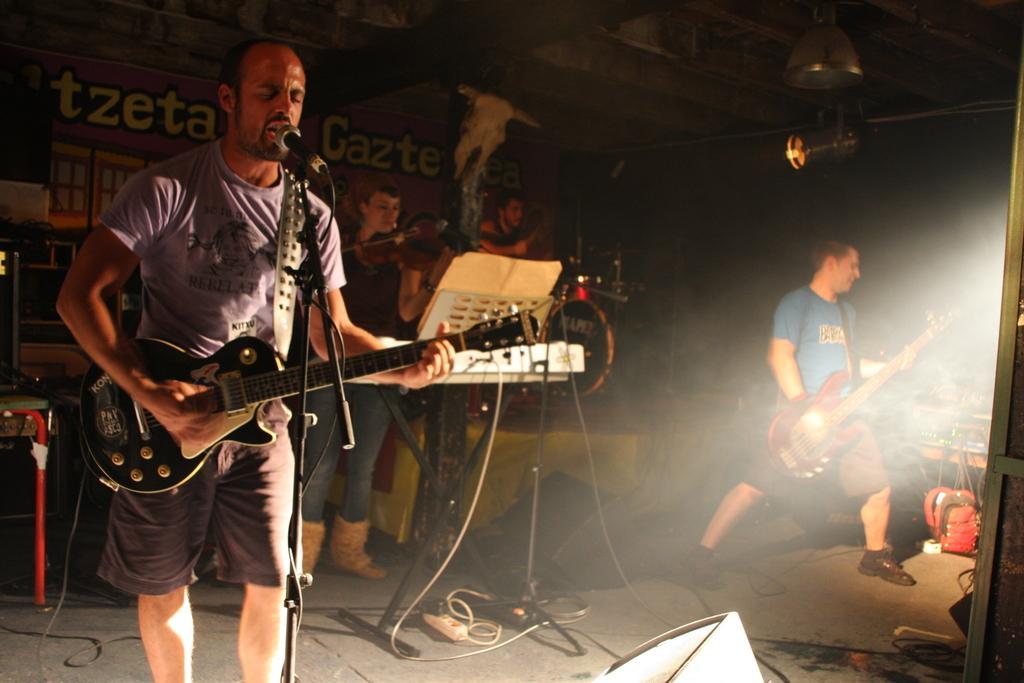How would you summarize this image in a sentence or two? In this image we can see three person standing and playing a musical instrument. On the floor there is a bag. At the back side there is a building. 